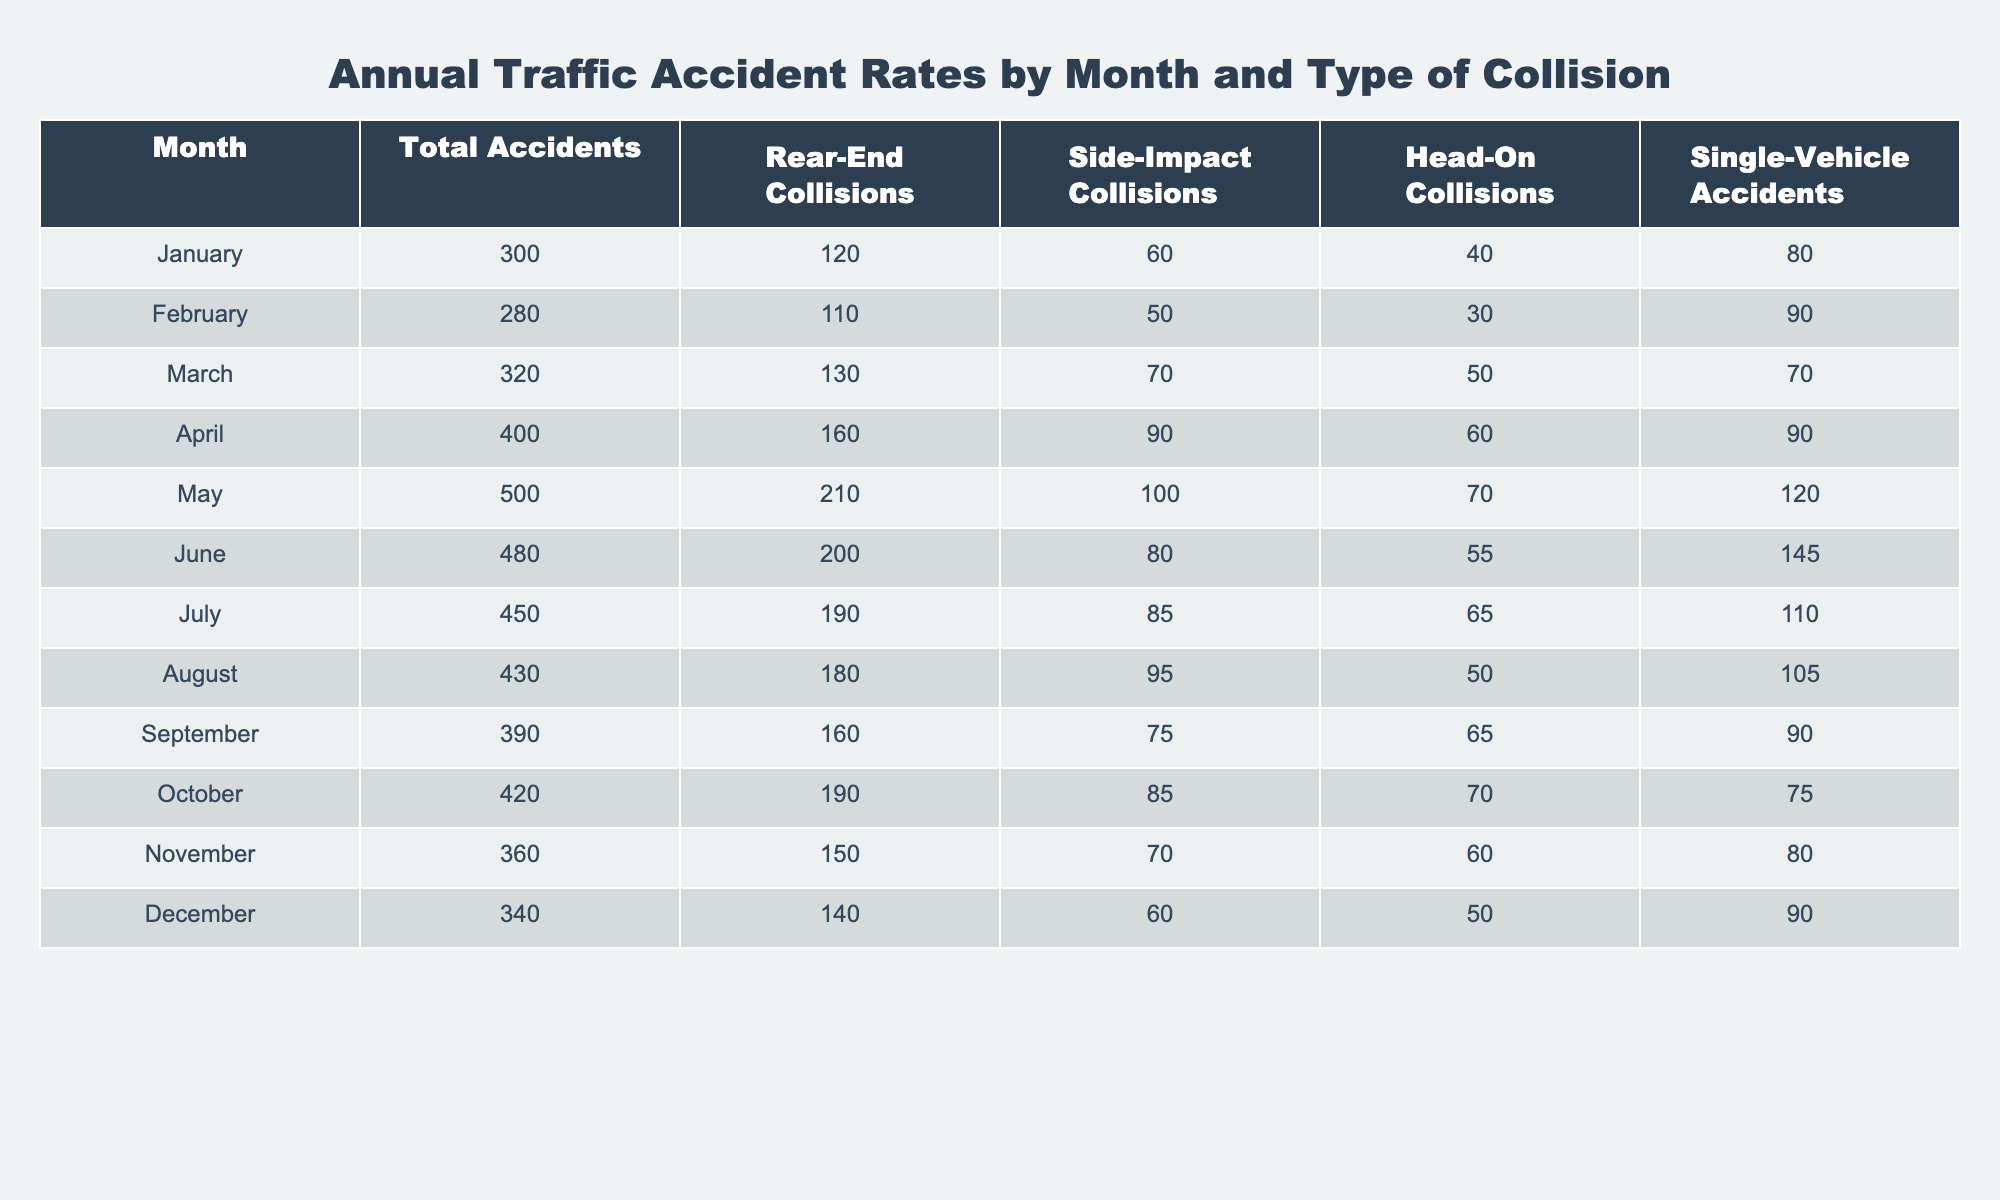What month had the highest total accidents? The total accidents are highest in April with 400 accidents, as seen in the "Total Accidents" column.
Answer: April What is the total number of rear-end collisions that occurred during the year? To find this, sum the rear-end collisions for all months: (120 + 110 + 130 + 160 + 210 + 200 + 190 + 180 + 160 + 190 + 150 + 140) = 1,750.
Answer: 1,750 Which month had the lowest number of side-impact collisions? The month with the lowest side-impact collisions is February, with only 50 incidents, as shown in the side-impact column.
Answer: February What is the average number of single-vehicle accidents per month? To calculate the average, sum the single-vehicle accidents: (80 + 90 + 70 + 90 + 120 + 145 + 110 + 105 + 90 + 75 + 80 + 90) = 1,330. Dividing by 12 months gives an average of 1,330 / 12 ≈ 111.67.
Answer: 111.67 Did the number of head-on collisions increase or decrease from January to June? In January, there were 40 head-on collisions, while in June, there were 55. This indicates an increase when comparing the two months.
Answer: Increase 